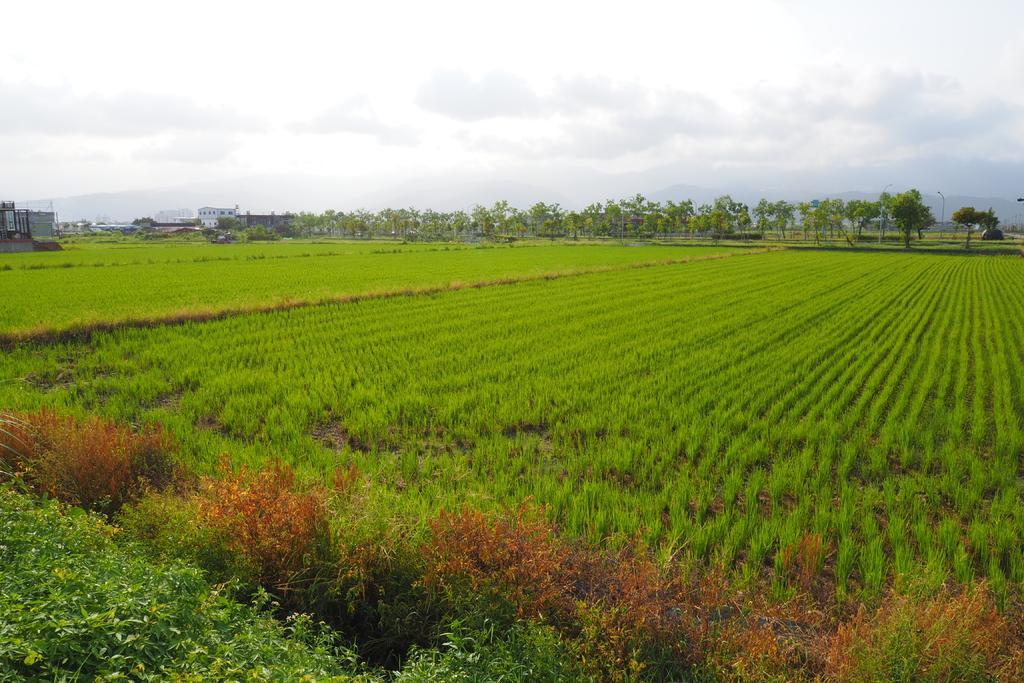Please provide a concise description of this image. In this image we can see group of plants, trees and in the background, we can see buildings and the cloudy sky. 